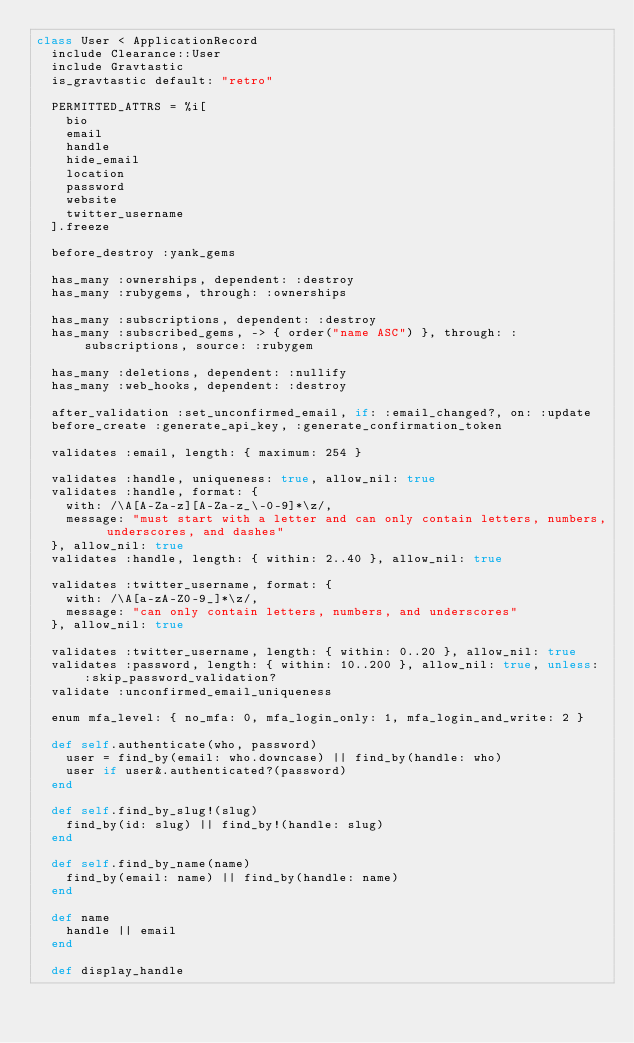<code> <loc_0><loc_0><loc_500><loc_500><_Ruby_>class User < ApplicationRecord
  include Clearance::User
  include Gravtastic
  is_gravtastic default: "retro"

  PERMITTED_ATTRS = %i[
    bio
    email
    handle
    hide_email
    location
    password
    website
    twitter_username
  ].freeze

  before_destroy :yank_gems

  has_many :ownerships, dependent: :destroy
  has_many :rubygems, through: :ownerships

  has_many :subscriptions, dependent: :destroy
  has_many :subscribed_gems, -> { order("name ASC") }, through: :subscriptions, source: :rubygem

  has_many :deletions, dependent: :nullify
  has_many :web_hooks, dependent: :destroy

  after_validation :set_unconfirmed_email, if: :email_changed?, on: :update
  before_create :generate_api_key, :generate_confirmation_token

  validates :email, length: { maximum: 254 }

  validates :handle, uniqueness: true, allow_nil: true
  validates :handle, format: {
    with: /\A[A-Za-z][A-Za-z_\-0-9]*\z/,
    message: "must start with a letter and can only contain letters, numbers, underscores, and dashes"
  }, allow_nil: true
  validates :handle, length: { within: 2..40 }, allow_nil: true

  validates :twitter_username, format: {
    with: /\A[a-zA-Z0-9_]*\z/,
    message: "can only contain letters, numbers, and underscores"
  }, allow_nil: true

  validates :twitter_username, length: { within: 0..20 }, allow_nil: true
  validates :password, length: { within: 10..200 }, allow_nil: true, unless: :skip_password_validation?
  validate :unconfirmed_email_uniqueness

  enum mfa_level: { no_mfa: 0, mfa_login_only: 1, mfa_login_and_write: 2 }

  def self.authenticate(who, password)
    user = find_by(email: who.downcase) || find_by(handle: who)
    user if user&.authenticated?(password)
  end

  def self.find_by_slug!(slug)
    find_by(id: slug) || find_by!(handle: slug)
  end

  def self.find_by_name(name)
    find_by(email: name) || find_by(handle: name)
  end

  def name
    handle || email
  end

  def display_handle</code> 